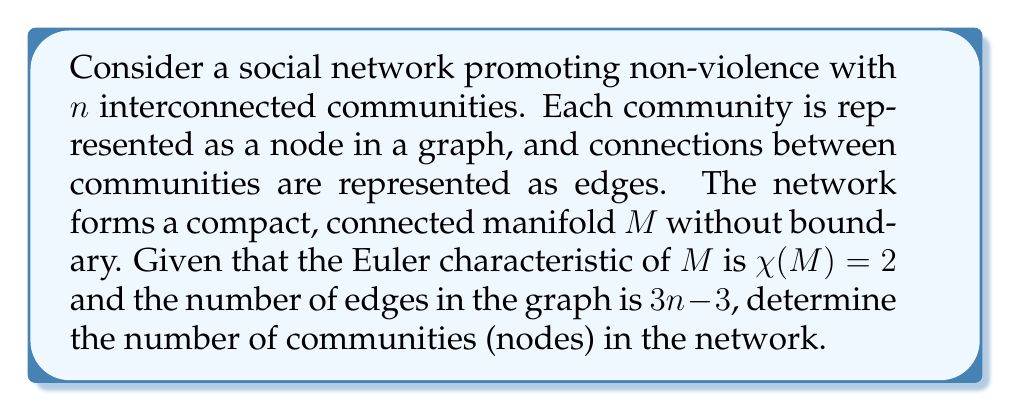Teach me how to tackle this problem. To solve this problem, we'll use concepts from algebraic topology and graph theory:

1) First, recall the Euler characteristic formula for a graph:
   $$\chi = V - E + F$$
   where $V$ is the number of vertices (nodes), $E$ is the number of edges, and $F$ is the number of faces.

2) We're given that $\chi(M) = 2$ and $E = 3n - 3$, where $n$ is the number of nodes.

3) For a compact, connected manifold without boundary, we can use the Euler-Poincaré formula:
   $$\chi(M) = \sum_{i=0}^{\dim M} (-1)^i b_i$$
   where $b_i$ are the Betti numbers of the manifold.

4) Since $\chi(M) = 2$, this implies that $M$ is topologically equivalent to a sphere (as the sphere is the only compact 2-manifold with Euler characteristic 2).

5) For a spherical graph, we can use Euler's polyhedron formula:
   $$V - E + F = 2$$

6) Substituting the known values:
   $$n - (3n - 3) + F = 2$$

7) Solving for $F$:
   $$F = 2 - n + (3n - 3) = 2n - 1$$

8) Now, we can use the relationship between faces, edges, and vertices in a planar graph:
   $$2E = 3F$$ (each edge borders 2 faces, each face has 3 edges)

9) Substituting the known values:
   $$2(3n - 3) = 3(2n - 1)$$

10) Simplifying:
    $$6n - 6 = 6n - 3$$
    $$-6 = -3$$
    $$3 = 3$$

11) This identity is true for any value of $n$, so we need additional information to determine $n$.

12) Recall that for a connected planar graph, Euler's formula gives:
    $$V - E + F = 2$$
    $$n - (3n - 3) + (2n - 1) = 2$$
    $$n = 6$$

Therefore, the number of communities (nodes) in the network is 6.
Answer: 6 communities (nodes) 